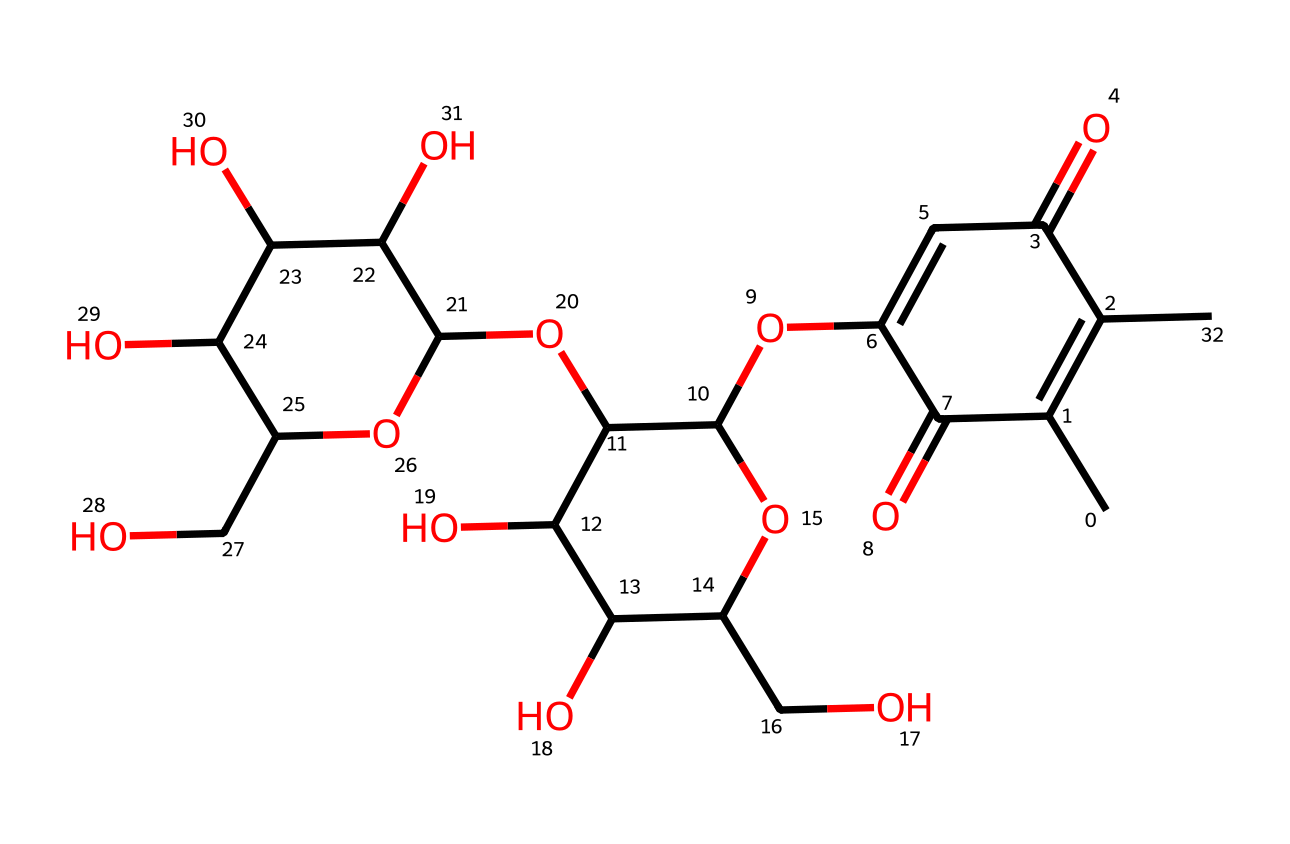What is the molecular formula of the compound represented by the SMILES? By analyzing the SMILES representation, we can count each type of atom present: there are multiple carbons (C), oxygens (O), and hydrogens (H). The molecular formula reflects the number of each type of atom, leading us to deduce C21H30O7.
Answer: C21H30O7 How many chiral centers exist in the molecule? A chiral center is typically a carbon atom that is bonded to four different substituents. Inspecting the structure, we can find six such carbon atoms that demonstrate chirality due to their different attached groups.
Answer: 6 What type of functional groups are present in this structure? Observing the chemical structure, we can identify several functional groups, including hydroxyl (-OH) groups and ester groups. This variety indicates that the molecule has alcohol and ether characteristics.
Answer: hydroxyl, ester What is the primary characteristic that classifies this chemical as a monomer? Monomers are typically small, reactive molecules that can join together to form polymers. The presence of multiple reactive functional sites in the SMILES indicates that this molecule can participate in such bonding processes, qualifying it as a monomer.
Answer: reactivity What is the expected solubility of this compound in water? Given the presence of multiple hydroxyl (-OH) groups, which are polar and can form hydrogen bonds with water, this compound is likely to be soluble in water.
Answer: soluble How many rings are present in the chemical structure? In analyzing the SMILES, we note that there are three distinct cyclic structures, which are connected in this compound. The count of individual rings indicates the complexity of the molecule and its structural integrity.
Answer: 3 